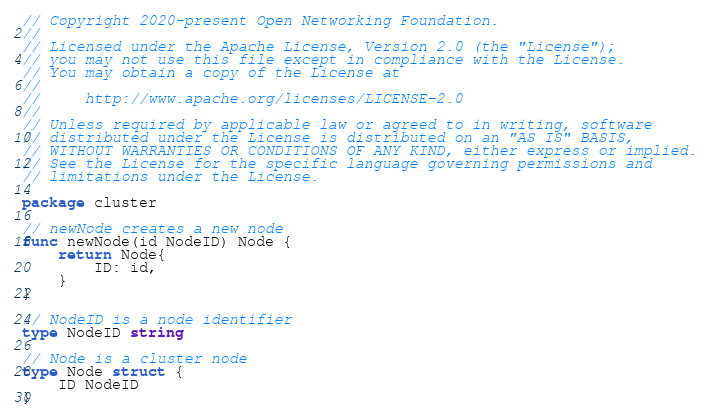<code> <loc_0><loc_0><loc_500><loc_500><_Go_>// Copyright 2020-present Open Networking Foundation.
//
// Licensed under the Apache License, Version 2.0 (the "License");
// you may not use this file except in compliance with the License.
// You may obtain a copy of the License at
//
//     http://www.apache.org/licenses/LICENSE-2.0
//
// Unless required by applicable law or agreed to in writing, software
// distributed under the License is distributed on an "AS IS" BASIS,
// WITHOUT WARRANTIES OR CONDITIONS OF ANY KIND, either express or implied.
// See the License for the specific language governing permissions and
// limitations under the License.

package cluster

// newNode creates a new node
func newNode(id NodeID) Node {
	return Node{
		ID: id,
	}
}

// NodeID is a node identifier
type NodeID string

// Node is a cluster node
type Node struct {
	ID NodeID
}
</code> 